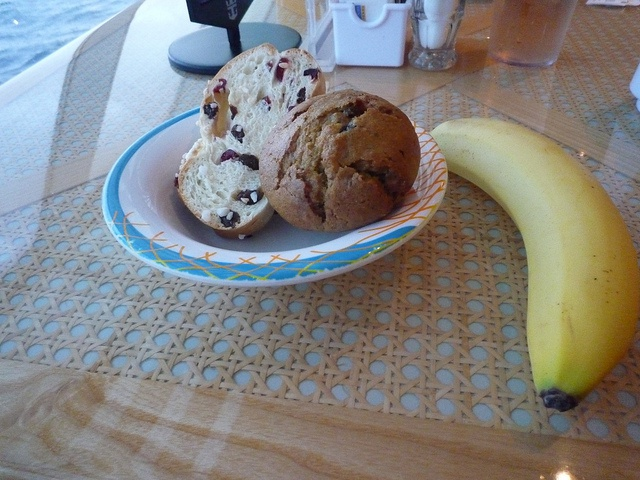Describe the objects in this image and their specific colors. I can see dining table in gray, darkgray, and tan tones, bowl in lightblue, darkgray, gray, and maroon tones, banana in lightblue, tan, olive, and beige tones, cake in lightblue, maroon, gray, darkgray, and black tones, and cup in lightblue, gray, brown, and maroon tones in this image. 